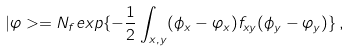Convert formula to latex. <formula><loc_0><loc_0><loc_500><loc_500>| \varphi > = N _ { f } e x p \{ - { \frac { 1 } { 2 } } \int _ { x , y } ( \phi _ { x } - \varphi _ { x } ) f _ { x y } ( \phi _ { y } - \varphi _ { y } ) \} \, ,</formula> 